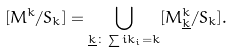Convert formula to latex. <formula><loc_0><loc_0><loc_500><loc_500>[ M ^ { k } / S _ { k } ] = \bigcup _ { \underline { k } \colon \sum i k _ { i } = k } [ M ^ { k } _ { \underline { k } } / S _ { k } ] .</formula> 